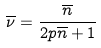Convert formula to latex. <formula><loc_0><loc_0><loc_500><loc_500>\overline { \nu } = \frac { \overline { n } } { 2 p \overline { n } + 1 }</formula> 